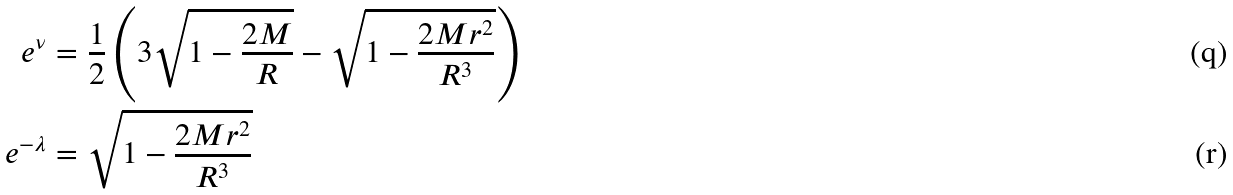Convert formula to latex. <formula><loc_0><loc_0><loc_500><loc_500>e ^ { \nu } & = \frac { 1 } { 2 } \left ( 3 \sqrt { 1 - \frac { 2 M } { R } } - \sqrt { 1 - \frac { 2 M r ^ { 2 } } { R ^ { 3 } } } \right ) \\ e ^ { - \lambda } & = \sqrt { 1 - \frac { 2 M r ^ { 2 } } { R ^ { 3 } } }</formula> 